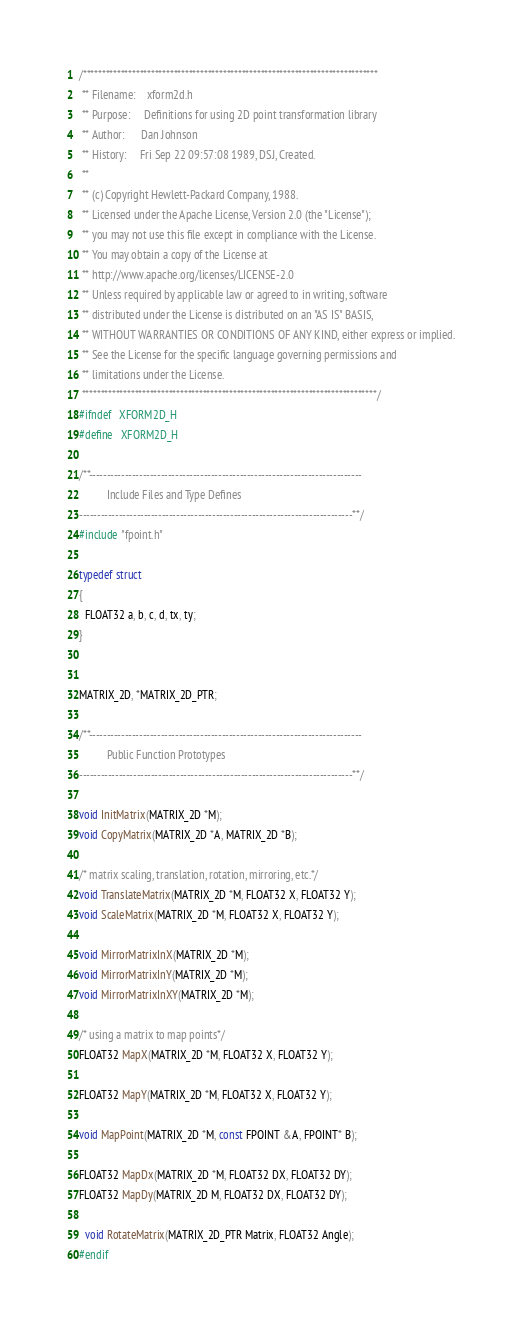Convert code to text. <code><loc_0><loc_0><loc_500><loc_500><_C_>/******************************************************************************
 ** Filename:    xform2d.h
 ** Purpose:     Definitions for using 2D point transformation library
 ** Author:      Dan Johnson
 ** History:     Fri Sep 22 09:57:08 1989, DSJ, Created.
 **
 ** (c) Copyright Hewlett-Packard Company, 1988.
 ** Licensed under the Apache License, Version 2.0 (the "License");
 ** you may not use this file except in compliance with the License.
 ** You may obtain a copy of the License at
 ** http://www.apache.org/licenses/LICENSE-2.0
 ** Unless required by applicable law or agreed to in writing, software
 ** distributed under the License is distributed on an "AS IS" BASIS,
 ** WITHOUT WARRANTIES OR CONDITIONS OF ANY KIND, either express or implied.
 ** See the License for the specific language governing permissions and
 ** limitations under the License.
 ******************************************************************************/
#ifndef   XFORM2D_H
#define   XFORM2D_H

/**----------------------------------------------------------------------------
          Include Files and Type Defines
----------------------------------------------------------------------------**/
#include "fpoint.h"

typedef struct
{
  FLOAT32 a, b, c, d, tx, ty;
}


MATRIX_2D, *MATRIX_2D_PTR;

/**----------------------------------------------------------------------------
          Public Function Prototypes
----------------------------------------------------------------------------**/

void InitMatrix(MATRIX_2D *M);
void CopyMatrix(MATRIX_2D *A, MATRIX_2D *B);

/* matrix scaling, translation, rotation, mirroring, etc.*/
void TranslateMatrix(MATRIX_2D *M, FLOAT32 X, FLOAT32 Y);
void ScaleMatrix(MATRIX_2D *M, FLOAT32 X, FLOAT32 Y);

void MirrorMatrixInX(MATRIX_2D *M);
void MirrorMatrixInY(MATRIX_2D *M);
void MirrorMatrixInXY(MATRIX_2D *M);

/* using a matrix to map points*/
FLOAT32 MapX(MATRIX_2D *M, FLOAT32 X, FLOAT32 Y);

FLOAT32 MapY(MATRIX_2D *M, FLOAT32 X, FLOAT32 Y);

void MapPoint(MATRIX_2D *M, const FPOINT &A, FPOINT* B);

FLOAT32 MapDx(MATRIX_2D *M, FLOAT32 DX, FLOAT32 DY);
FLOAT32 MapDy(MATRIX_2D M, FLOAT32 DX, FLOAT32 DY);

  void RotateMatrix(MATRIX_2D_PTR Matrix, FLOAT32 Angle);
#endif
</code> 